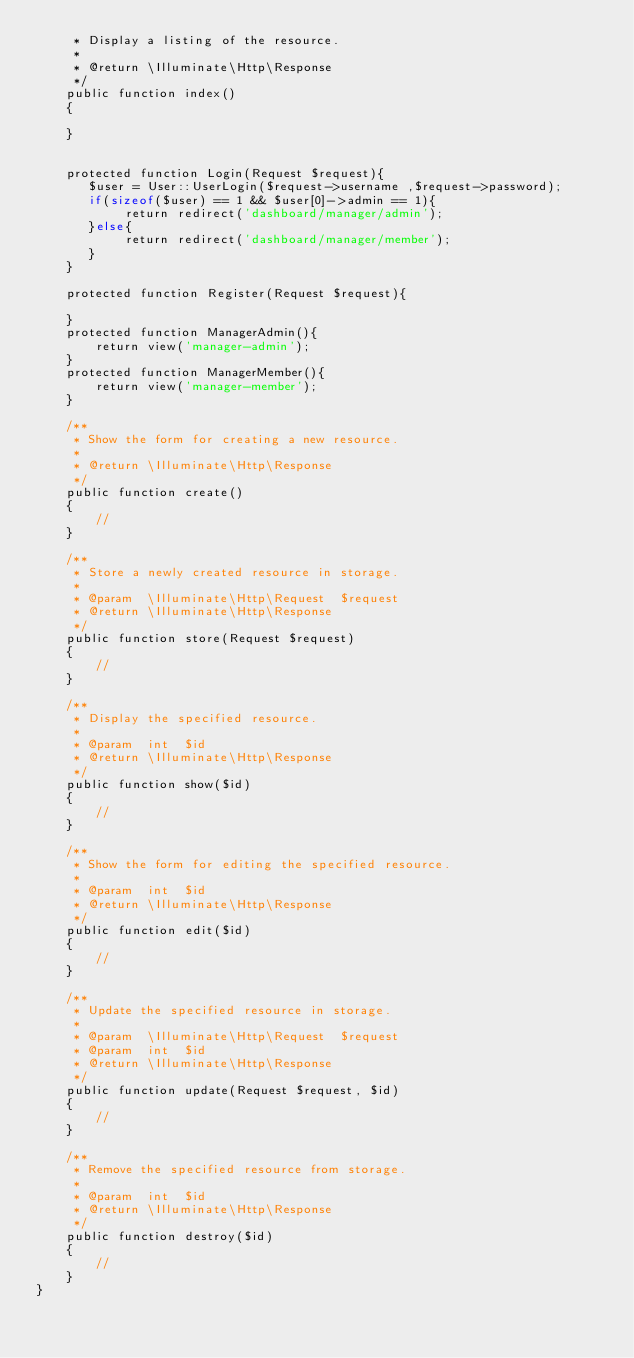<code> <loc_0><loc_0><loc_500><loc_500><_PHP_>     * Display a listing of the resource.
     *
     * @return \Illuminate\Http\Response
     */
    public function index()
    {

    }


    protected function Login(Request $request){
       $user = User::UserLogin($request->username ,$request->password);
       if(sizeof($user) == 1 && $user[0]->admin == 1){
            return redirect('dashboard/manager/admin');
       }else{
            return redirect('dashboard/manager/member');
       }
    }

    protected function Register(Request $request){

    }
    protected function ManagerAdmin(){
        return view('manager-admin');
    }
    protected function ManagerMember(){
        return view('manager-member');
    }

    /**
     * Show the form for creating a new resource.
     *
     * @return \Illuminate\Http\Response
     */
    public function create()
    {
        //
    }

    /**
     * Store a newly created resource in storage.
     *
     * @param  \Illuminate\Http\Request  $request
     * @return \Illuminate\Http\Response
     */
    public function store(Request $request)
    {
        //
    }

    /**
     * Display the specified resource.
     *
     * @param  int  $id
     * @return \Illuminate\Http\Response
     */
    public function show($id)
    {
        //
    }

    /**
     * Show the form for editing the specified resource.
     *
     * @param  int  $id
     * @return \Illuminate\Http\Response
     */
    public function edit($id)
    {
        //
    }

    /**
     * Update the specified resource in storage.
     *
     * @param  \Illuminate\Http\Request  $request
     * @param  int  $id
     * @return \Illuminate\Http\Response
     */
    public function update(Request $request, $id)
    {
        //
    }

    /**
     * Remove the specified resource from storage.
     *
     * @param  int  $id
     * @return \Illuminate\Http\Response
     */
    public function destroy($id)
    {
        //
    }
}
</code> 